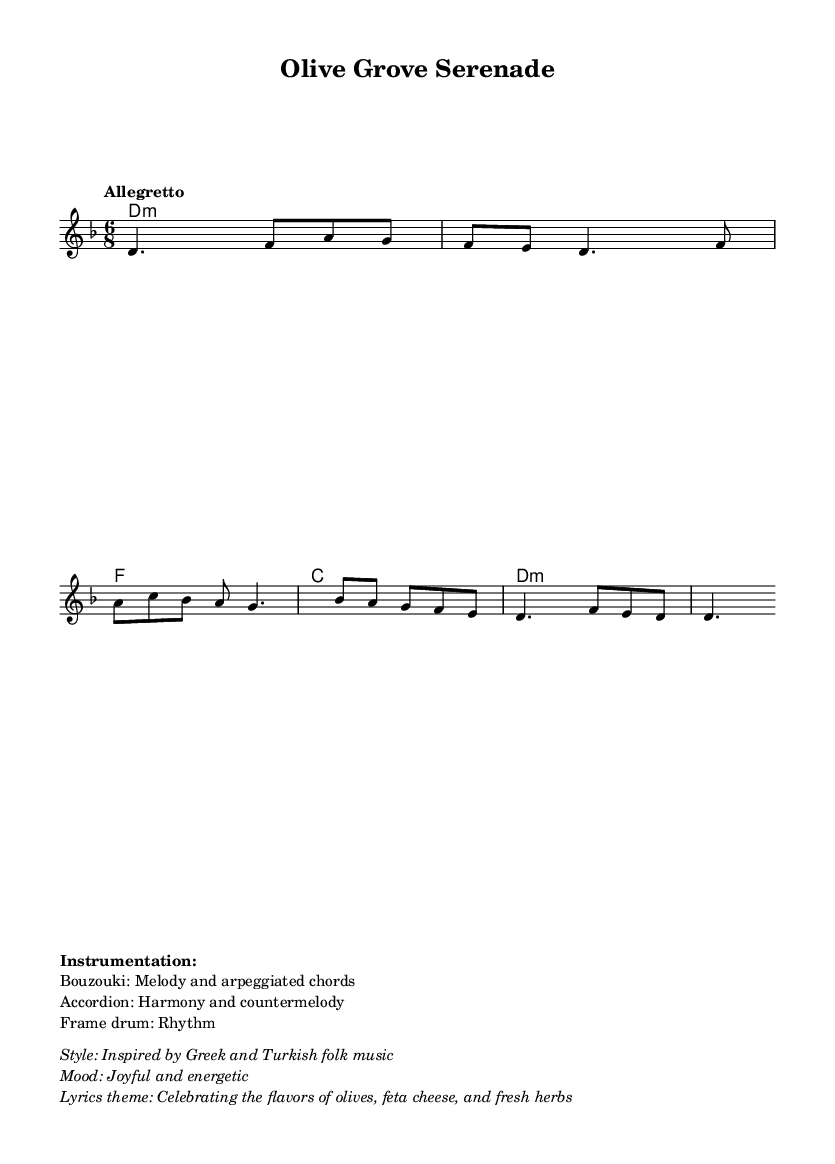What is the key signature of this music? The key signature is indicated at the beginning of the music staff, which shows two flats, aligning with the D minor scale.
Answer: D minor What is the time signature of the piece? The time signature is found in the beginning segment of the sheet music, which is indicated by the notation "6/8".
Answer: 6/8 What tempo marking is indicated for this piece? The tempo is described in the beginning as "Allegretto," which is associated with a moderate speed.
Answer: Allegretto What instruments are featured in this composition? The instrumentation is listed in the markup section: Bouzouki, Accordion, and Frame drum.
Answer: Bouzouki, Accordion, Frame drum How many measures are there in the melody section? Counting the measures in the melody line indicates a series of eight distinct measures present.
Answer: 8 What mood is conveyed through the music? The mood is described in the markup as "Joyful and energetic," reflecting the lively nature of the piece.
Answer: Joyful and energetic Which foods are mentioned in the lyrics theme? The lyrics theme highlights specific foods such as olives, feta cheese, and fresh herbs, celebrating their flavors.
Answer: Olives, feta cheese, fresh herbs 